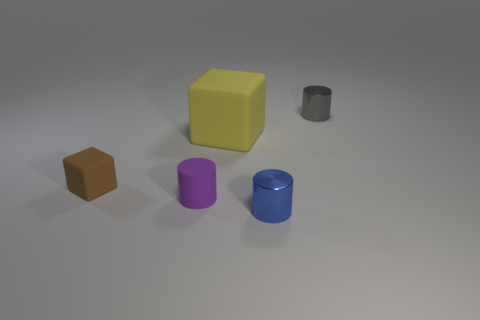Add 1 small gray objects. How many objects exist? 6 Subtract all purple matte cylinders. How many cylinders are left? 2 Subtract all gray cylinders. How many cylinders are left? 2 Subtract all red cubes. How many purple cylinders are left? 1 Add 2 tiny cyan matte balls. How many tiny cyan matte balls exist? 2 Subtract 0 blue spheres. How many objects are left? 5 Subtract all cylinders. How many objects are left? 2 Subtract 1 cylinders. How many cylinders are left? 2 Subtract all gray cylinders. Subtract all yellow balls. How many cylinders are left? 2 Subtract all cylinders. Subtract all brown spheres. How many objects are left? 2 